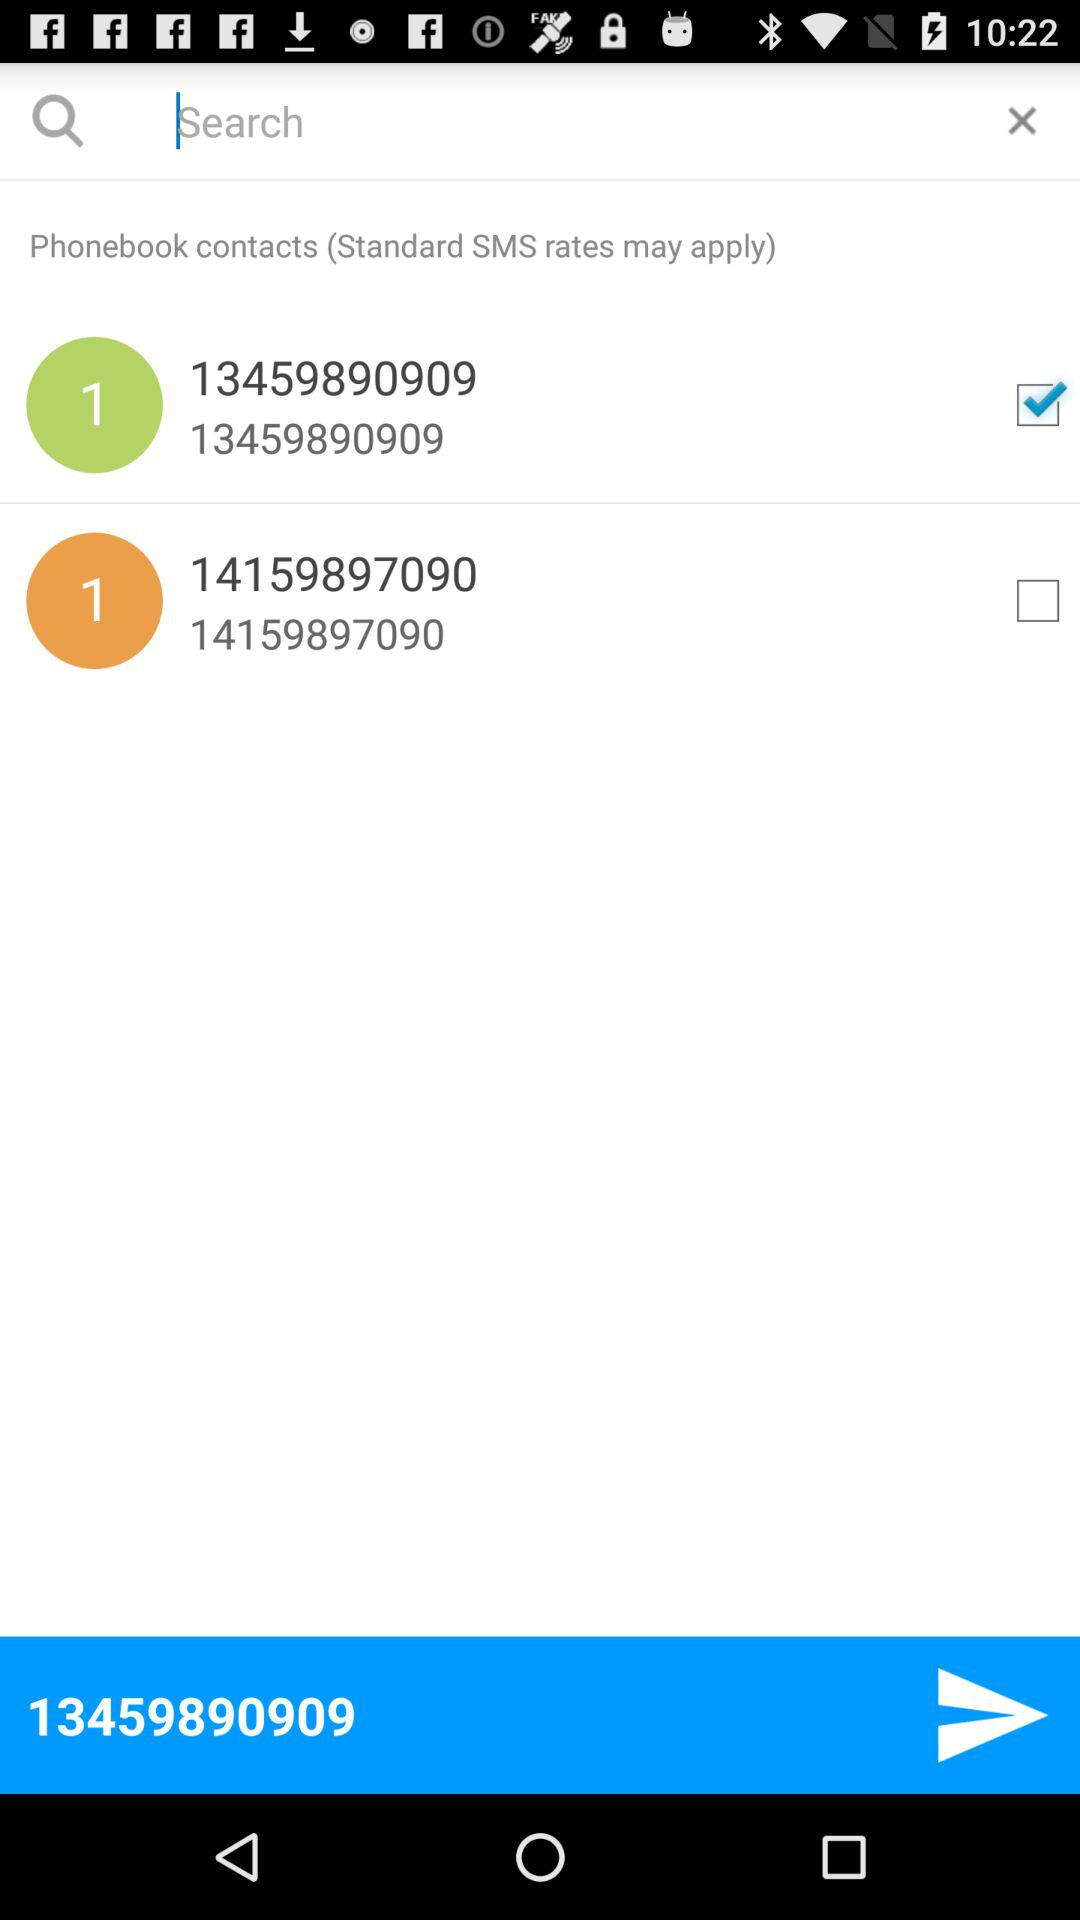What phone number is selected to send a message? The phone number selected to send the message is 13459890909. 